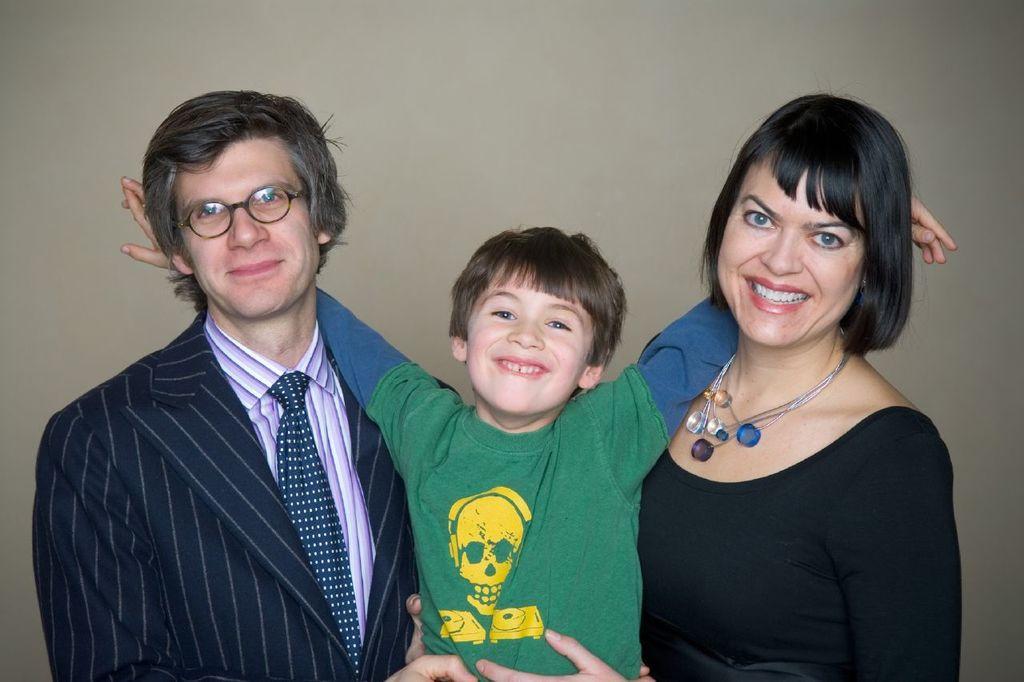Could you give a brief overview of what you see in this image? In this image I can see a three people smiling. The woman is wearing black top,man is wearing black coat and child is wearing yellow,green and blue color. Background is in grey color. 